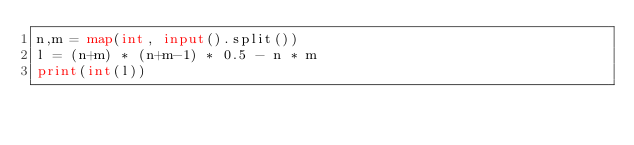<code> <loc_0><loc_0><loc_500><loc_500><_Python_>n,m = map(int, input().split())
l = (n+m) * (n+m-1) * 0.5 - n * m
print(int(l))</code> 